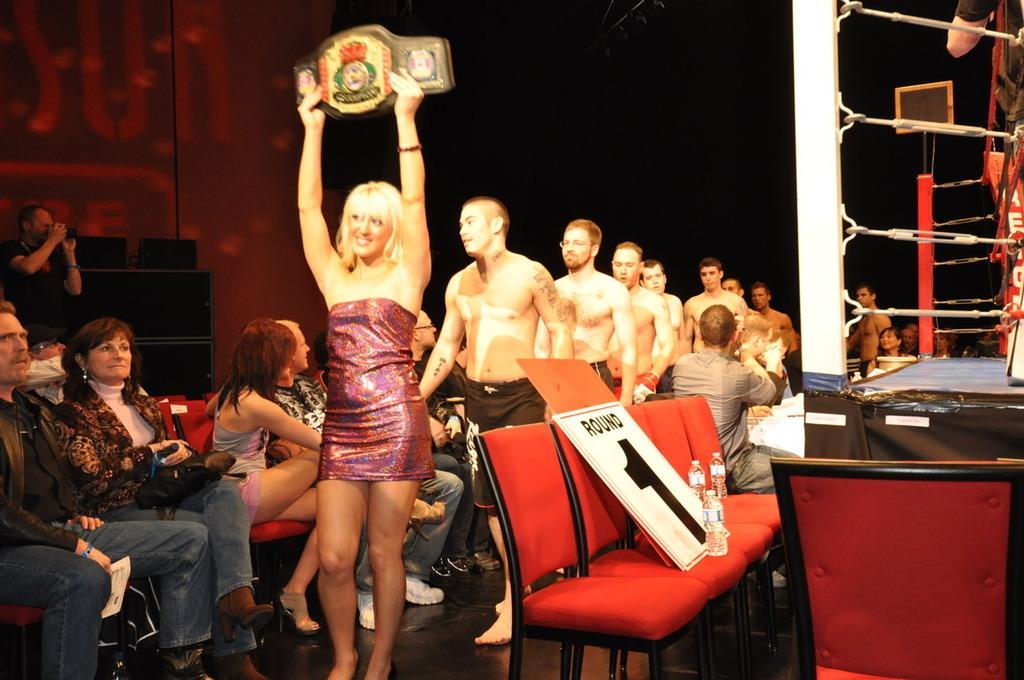What is the primary subject of the image? There is a woman in the image. What is the woman doing in the image? The woman is standing in the image. What object is the woman holding? The woman is holding a belt in the image. Are there any other people in the image besides the woman? Yes, there are men standing in the image. What are some people in the image doing besides standing? There are people sitting on chairs in the image. What type of ball can be seen rolling on the floor in the image? There is no ball present in the image; it features a woman standing and holding a belt, men standing, and people sitting on chairs. 